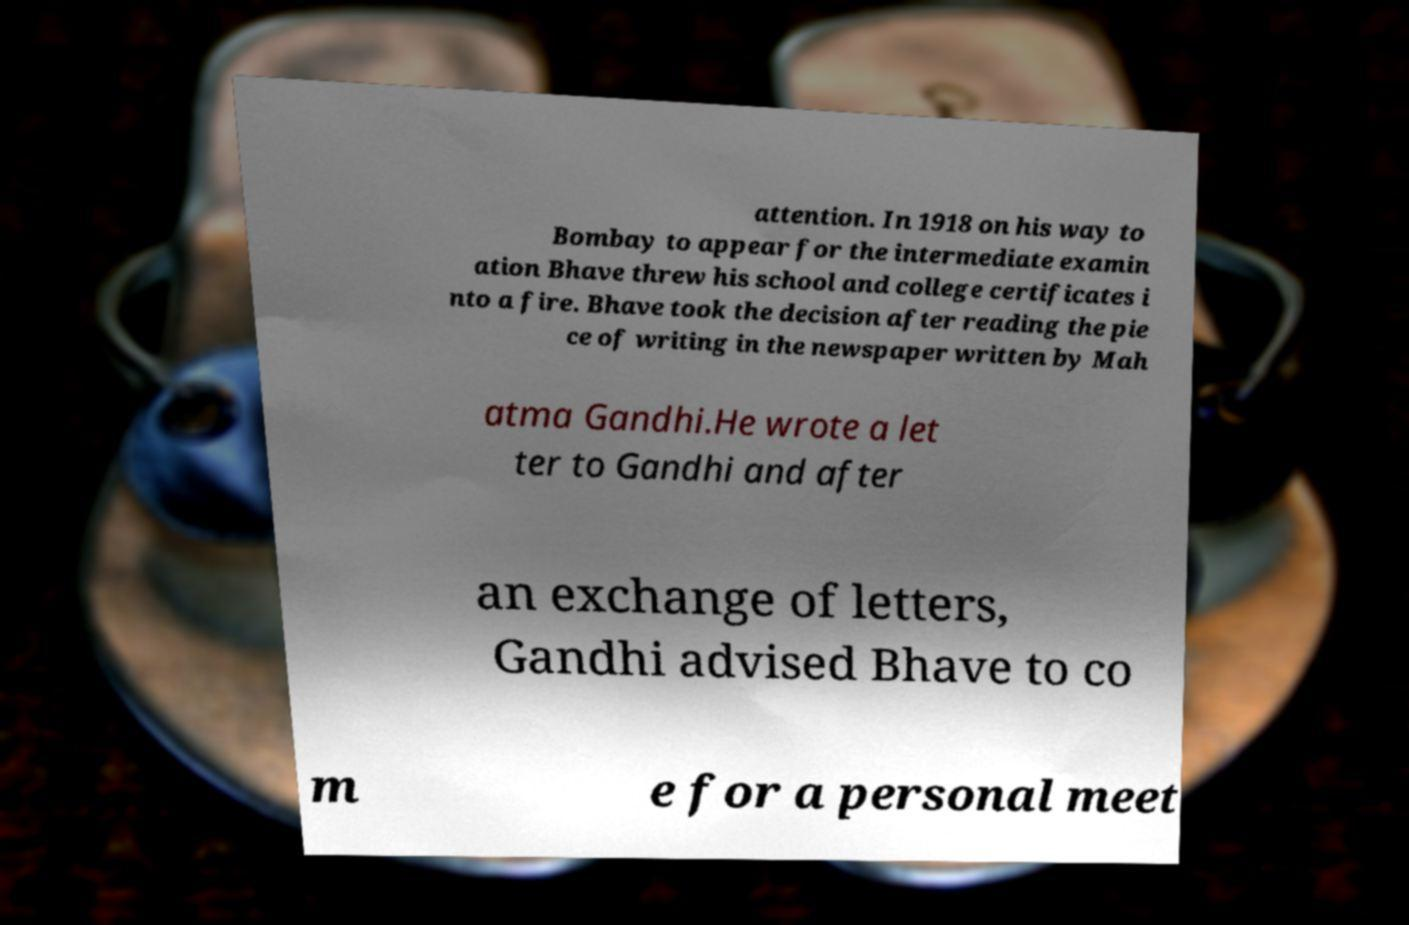There's text embedded in this image that I need extracted. Can you transcribe it verbatim? attention. In 1918 on his way to Bombay to appear for the intermediate examin ation Bhave threw his school and college certificates i nto a fire. Bhave took the decision after reading the pie ce of writing in the newspaper written by Mah atma Gandhi.He wrote a let ter to Gandhi and after an exchange of letters, Gandhi advised Bhave to co m e for a personal meet 